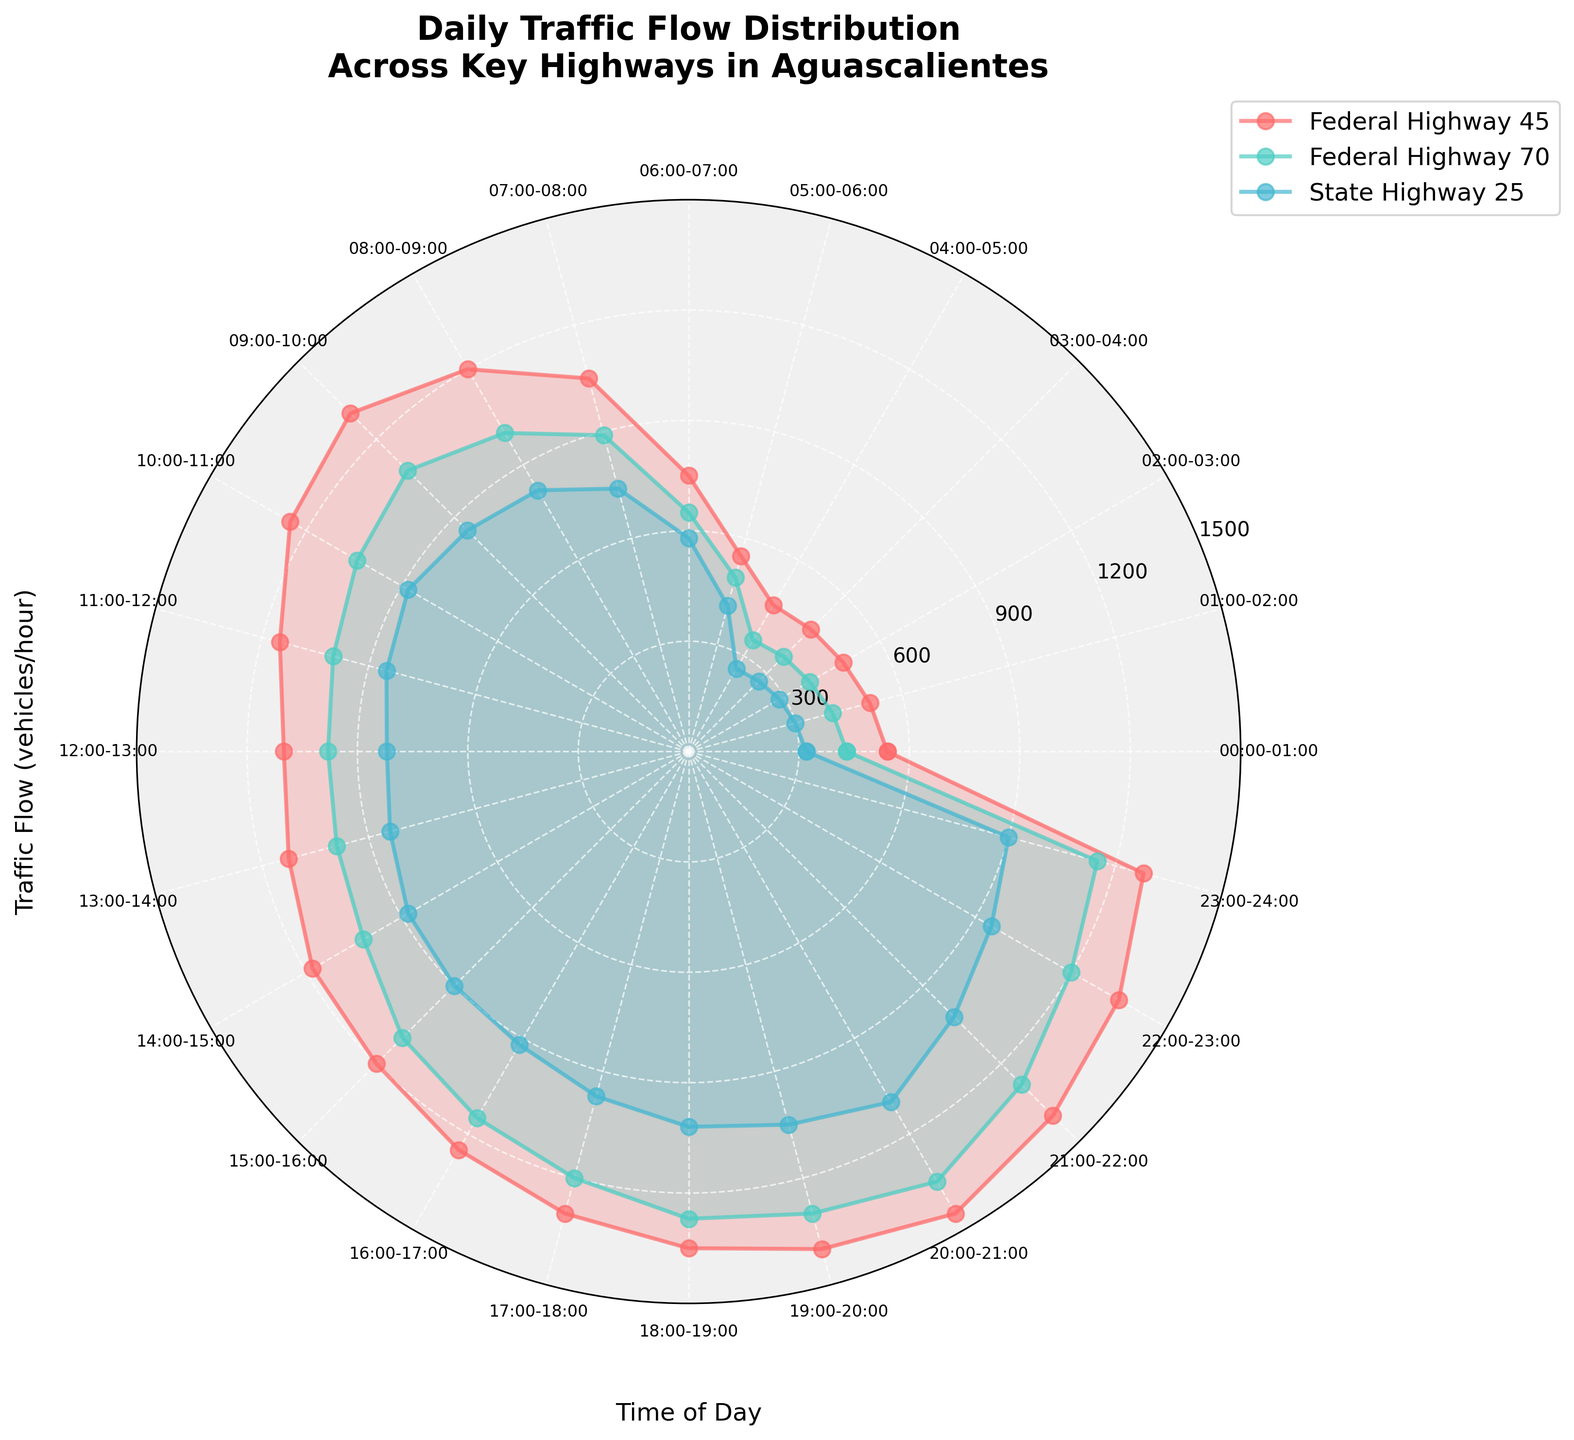What's the title of the figure? The title of the figure is located at the top and is typically larger and bolder than other text elements.
Answer: Daily Traffic Flow Distribution Across Key Highways in Aguascalientes How many highways are represented in the figure? There are three distinct color-coded lines and legends corresponding to the names of highways in the figure.
Answer: Three Between which time slots does the Federal Highway 45 have the highest traffic flow? By following the Federal Highway 45 line (the red one), you can see that the traffic flow is highest around 20:00-21:00.
Answer: 20:00-21:00 What is the traffic flow for State Highway 25 at 09:00-10:00? Look for the intersection point of the line representing State Highway 25 (the blue one) and the time slot 09:00-10:00. The traffic flow there is around 850 vehicles/hour.
Answer: 850 vehicles/hour At what time does Federal Highway 70 see a significant increase in traffic flow during the morning? Observe the green line for Federal Highway 70. There's a noticeable spike in traffic around 06:00-08:00, with the highest increase starting at 06:00.
Answer: 06:00 During which hours does the traffic flow on Federal Highway 45 and State Highway 25 appear equal? Compare the red and blue lines across the time slots. Both lines show equal traffic flow of around 1280 vehicles/hour at the 23:00-24:00 time slot.
Answer: 23:00-24:00 Which highway has the most consistent traffic flow throughout the day? By observing the three lines, the one with the least peaks and troughs is the green line representing State Highway 25. This means it has the most consistent traffic flow.
Answer: State Highway 25 Compare the peak traffic flow on Federal Highway 45 and Federal Highway 70. Which one is higher, and by how much? The peak traffic flow on Federal Highway 45 is 1450 vehicles/hour, whereas for Federal Highway 70 it is 1350 vehicles/hour. The difference is 1450 - 1350 = 100 vehicles/hour.
Answer: Federal Highway 45 by 100 vehicles/hour What is the average traffic flow on State Highway 25 between 18:00-21:00? Traffic flows during 18:00-19:00, 19:00-20:00, and 20:00-21:00 are 1020, 1050, and 1100 vehicles/hour respectively. Average = (1020 + 1050 + 1100) / 3 = 1056.67 vehicles/hour.
Answer: 1056.67 vehicles/hour What time does the traffic flow on Federal Highway 70 drop below 500 vehicles/hour? Observe the green line and find the point where it crosses below the 500 mark. This occurs around 05:00-06:00.
Answer: 05:00-06:00 